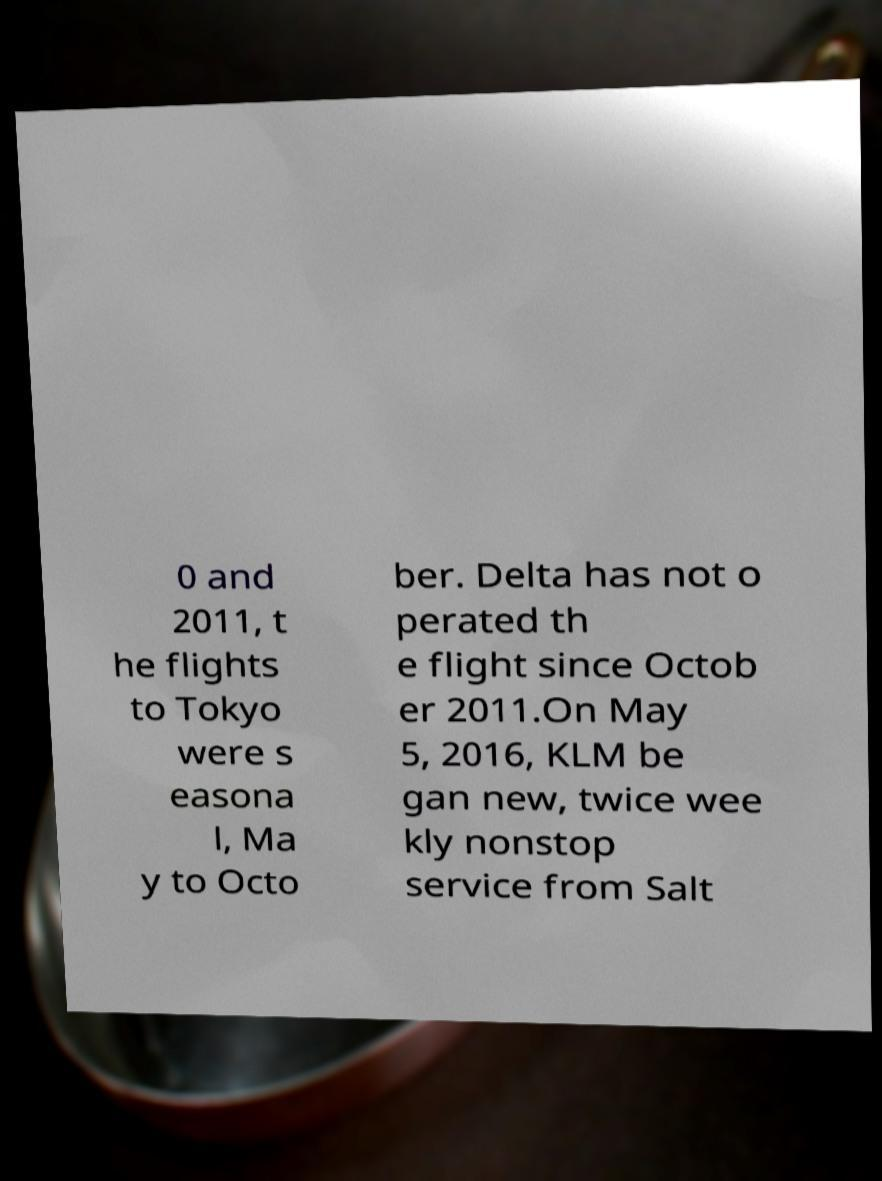Could you assist in decoding the text presented in this image and type it out clearly? 0 and 2011, t he flights to Tokyo were s easona l, Ma y to Octo ber. Delta has not o perated th e flight since Octob er 2011.On May 5, 2016, KLM be gan new, twice wee kly nonstop service from Salt 